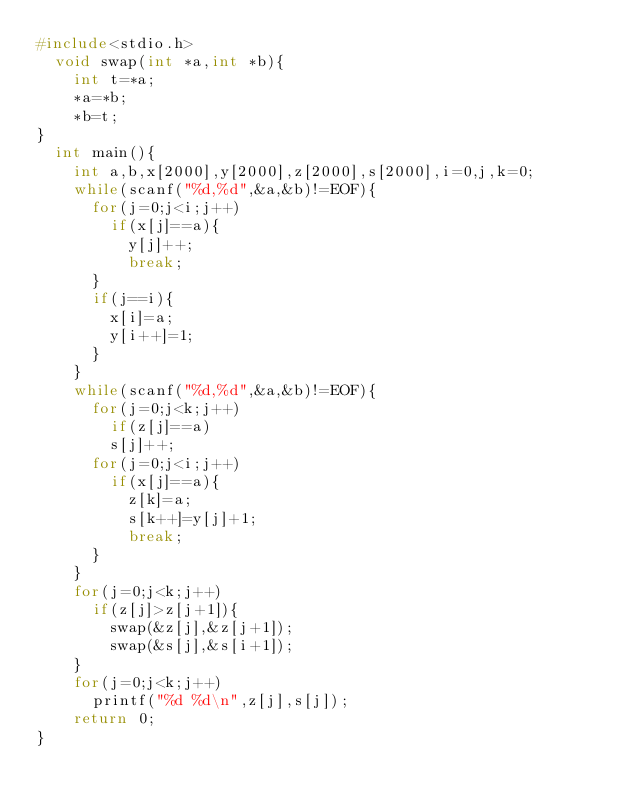Convert code to text. <code><loc_0><loc_0><loc_500><loc_500><_C_>#include<stdio.h>
	void swap(int *a,int *b){
		int t=*a;
		*a=*b;
		*b=t;
}
	int main(){
		int a,b,x[2000],y[2000],z[2000],s[2000],i=0,j,k=0;
		while(scanf("%d,%d",&a,&b)!=EOF){
			for(j=0;j<i;j++)
				if(x[j]==a){
					y[j]++;
					break;
			}
			if(j==i){
				x[i]=a;
				y[i++]=1;
			}
		}
		while(scanf("%d,%d",&a,&b)!=EOF){
			for(j=0;j<k;j++)
				if(z[j]==a)
				s[j]++;
			for(j=0;j<i;j++)
				if(x[j]==a){
					z[k]=a;
					s[k++]=y[j]+1;
					break;
			}
		}
		for(j=0;j<k;j++)
			if(z[j]>z[j+1]){
				swap(&z[j],&z[j+1]);
				swap(&s[j],&s[i+1]);
		}
		for(j=0;j<k;j++)
			printf("%d %d\n",z[j],s[j]);
		return 0;
}</code> 